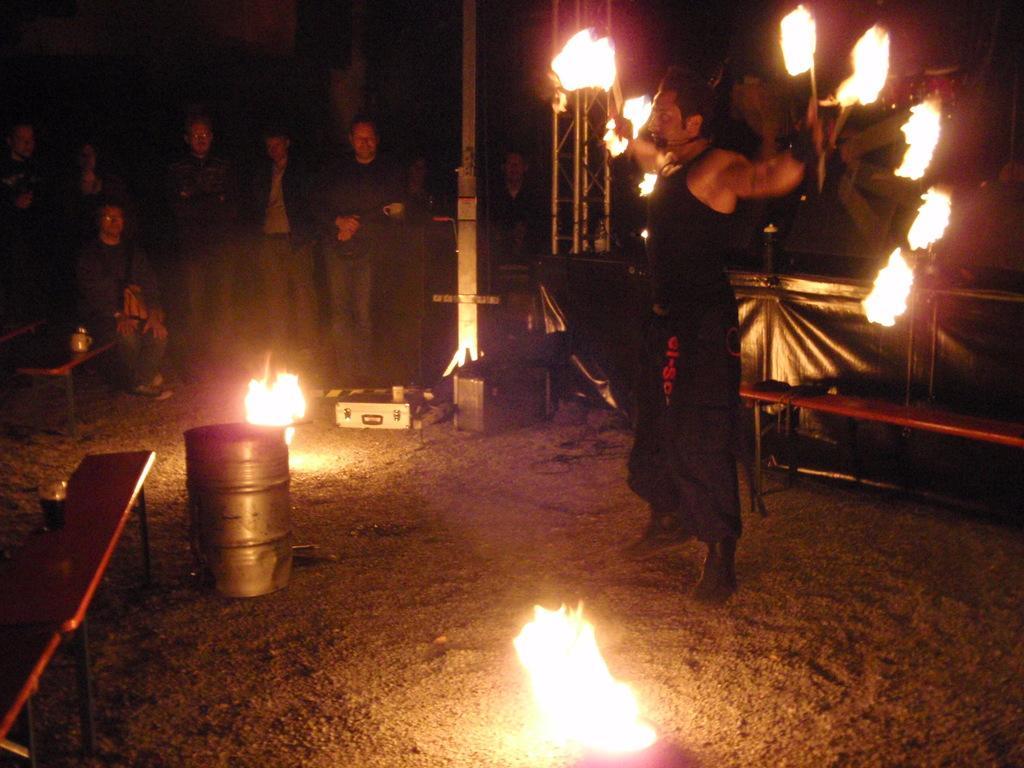Describe this image in one or two sentences. This image is taken outdoors. At the bottom of the image there is a ground. On the left side of the image there are three benches on the ground and there is a drum. In the background a few people are standing and a few are sitting. On the right side of the image a man is standing on the ground and he is holding sticks with fire in his hands and there is an empty bench. 